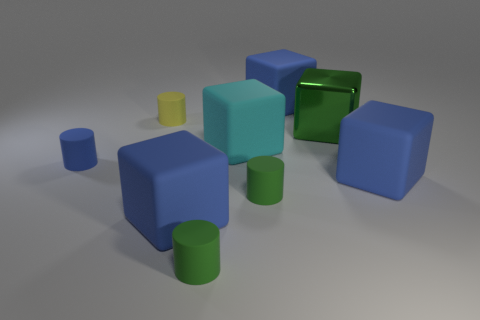How many blue blocks must be subtracted to get 1 blue blocks? 2 Subtract all rubber blocks. How many blocks are left? 1 Subtract all blue blocks. How many blocks are left? 2 Add 1 big blue cylinders. How many objects exist? 10 Subtract 0 purple spheres. How many objects are left? 9 Subtract all cylinders. How many objects are left? 5 Subtract 3 cylinders. How many cylinders are left? 1 Subtract all red cylinders. Subtract all purple blocks. How many cylinders are left? 4 Subtract all blue blocks. How many yellow cylinders are left? 1 Subtract all large cyan cubes. Subtract all small yellow rubber cylinders. How many objects are left? 7 